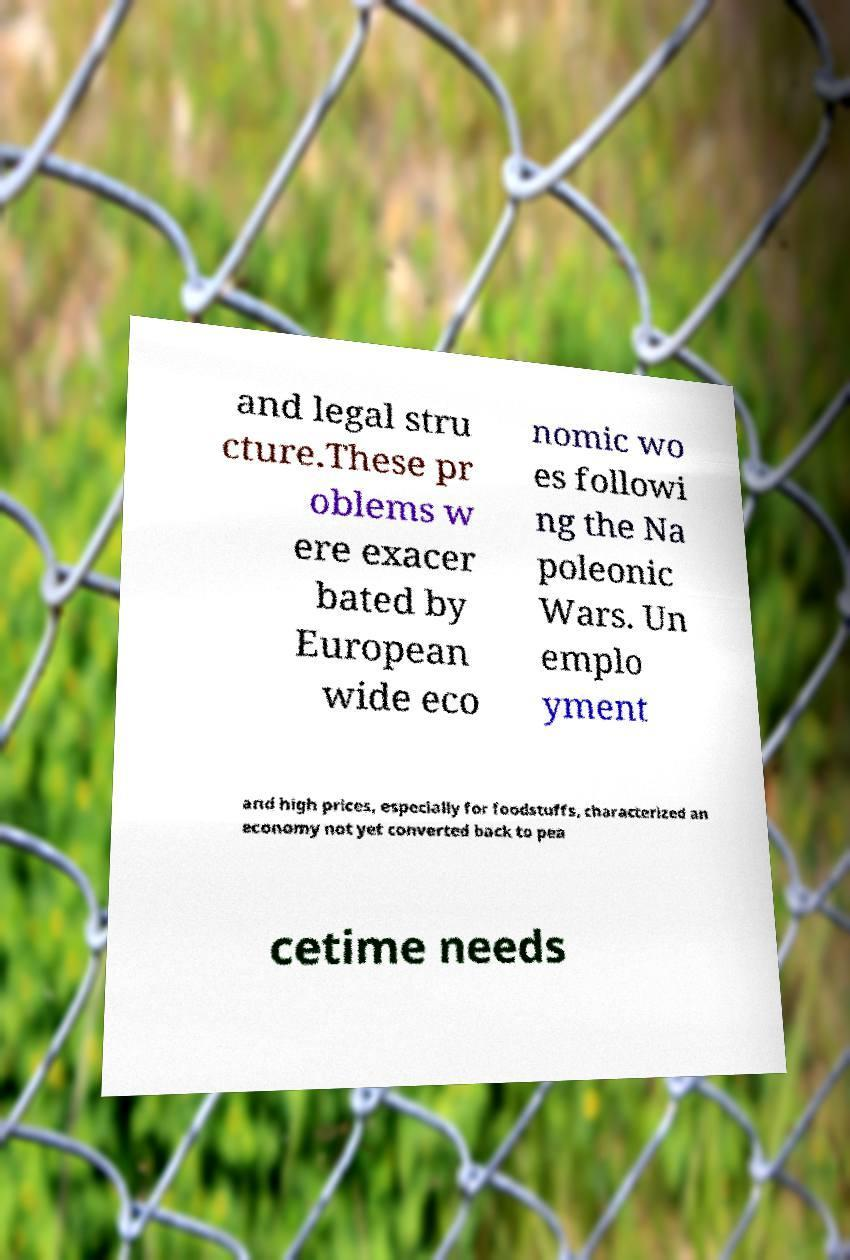There's text embedded in this image that I need extracted. Can you transcribe it verbatim? and legal stru cture.These pr oblems w ere exacer bated by European wide eco nomic wo es followi ng the Na poleonic Wars. Un emplo yment and high prices, especially for foodstuffs, characterized an economy not yet converted back to pea cetime needs 